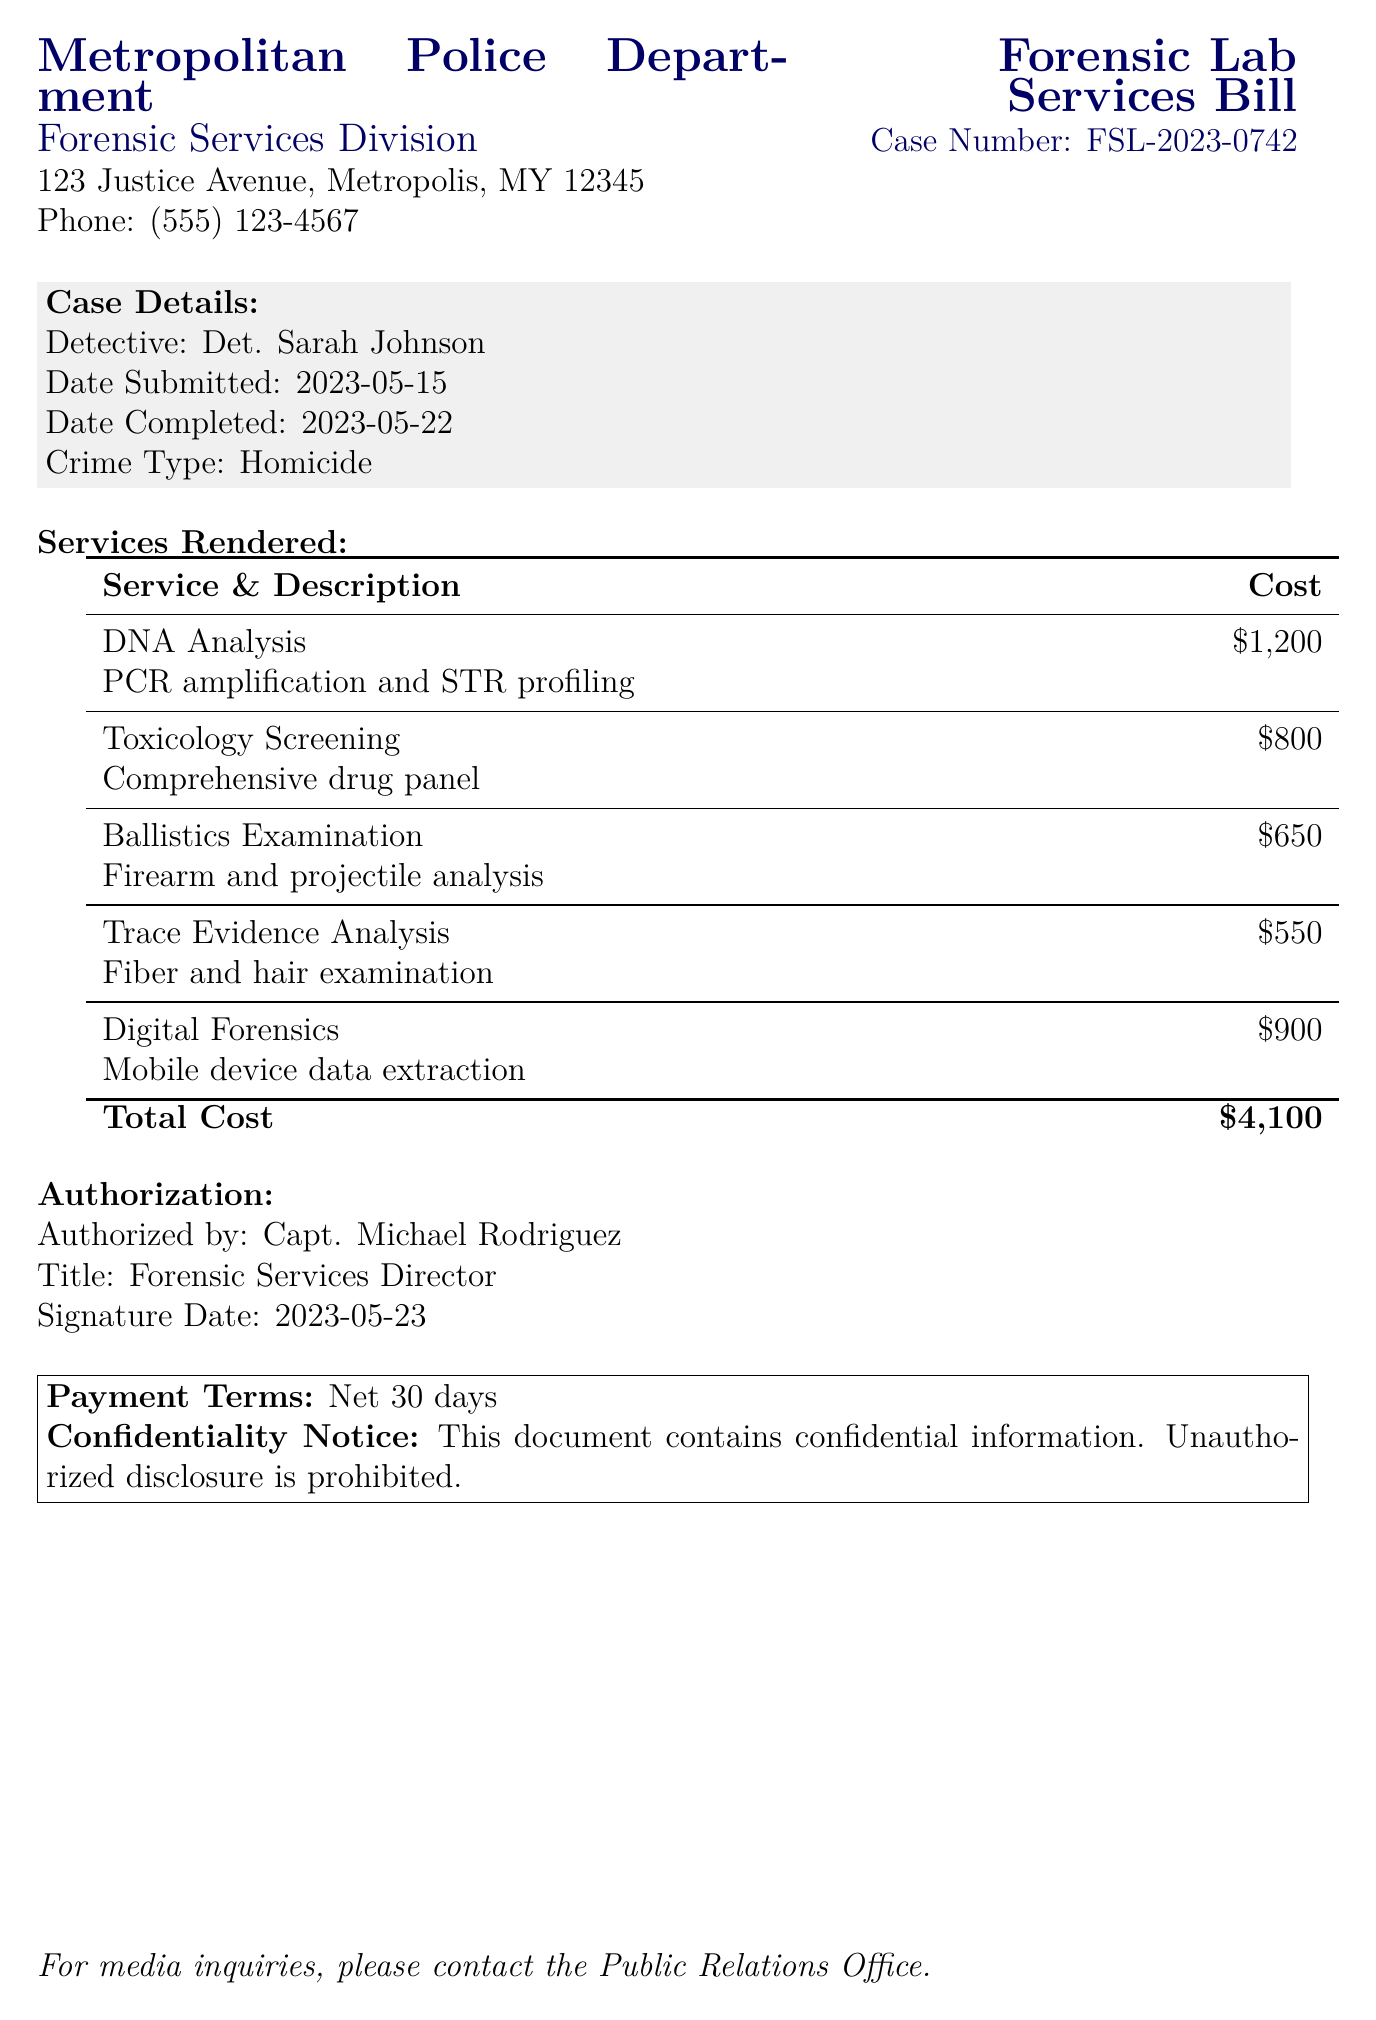What is the case number? The case number is specifically mentioned in the document under the title section.
Answer: FSL-2023-0742 Who authorized the forensic services bill? The document states the name of the individual who authorized the bill in the authorization section.
Answer: Capt. Michael Rodriguez What is the total cost of the services rendered? The total cost is calculated from the individual costs listed in the services rendered table.
Answer: $4,100 What type of crime is being investigated? The document specifies the type of crime associated with the case details.
Answer: Homicide What service has the highest cost? This can be determined by comparing the individual costs of each service listed in the document.
Answer: DNA Analysis On what date was the bill submitted? The submission date is clearly mentioned in the case details section of the document.
Answer: 2023-05-15 How many services are listed in the document? Counting the services in the provided table gives the total number of services rendered.
Answer: 5 What is the payment term specified in the document? The payment term is explicitly stated in the payment terms section at the end of the document.
Answer: Net 30 days What is the date completed for the forensic services? The completion date is included in the case details of the document.
Answer: 2023-05-22 